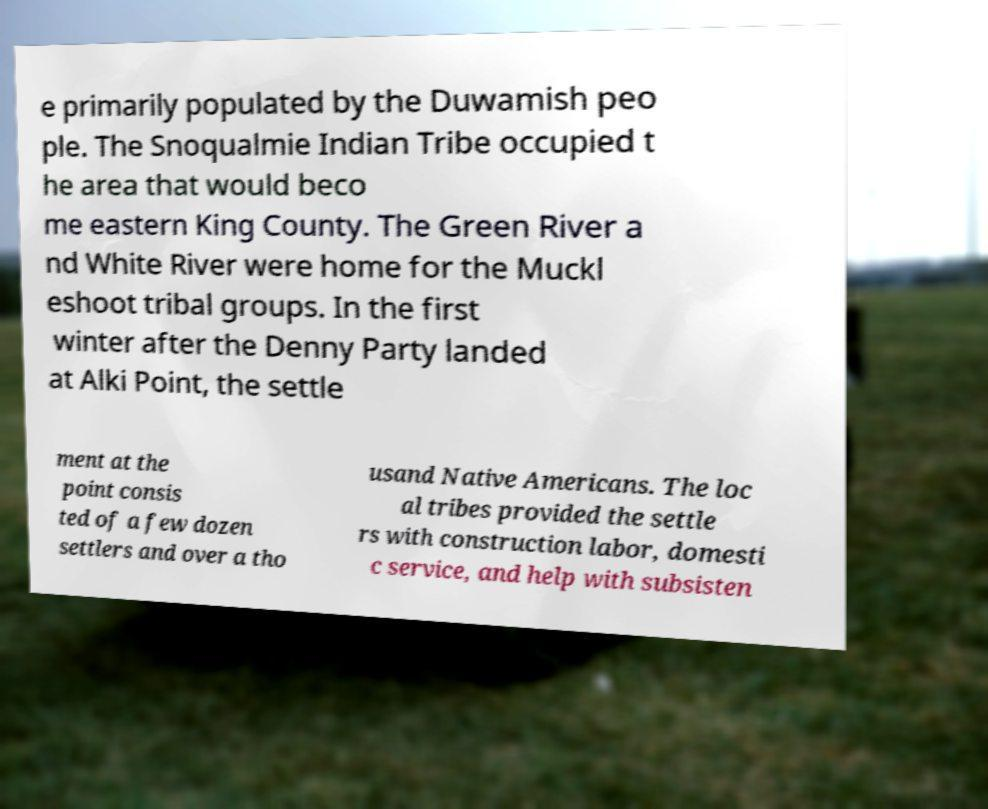I need the written content from this picture converted into text. Can you do that? e primarily populated by the Duwamish peo ple. The Snoqualmie Indian Tribe occupied t he area that would beco me eastern King County. The Green River a nd White River were home for the Muckl eshoot tribal groups. In the first winter after the Denny Party landed at Alki Point, the settle ment at the point consis ted of a few dozen settlers and over a tho usand Native Americans. The loc al tribes provided the settle rs with construction labor, domesti c service, and help with subsisten 